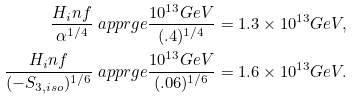<formula> <loc_0><loc_0><loc_500><loc_500>\frac { H _ { i } n f } { \alpha ^ { 1 / 4 } } & \ a p p r g e \frac { 1 0 ^ { 1 3 } G e V } { ( . 4 ) ^ { 1 / 4 } } = 1 . 3 \times 1 0 ^ { 1 3 } G e V , \\ \frac { H _ { i } n f } { ( - S _ { 3 , i s o } ) ^ { 1 / 6 } } & \ a p p r g e \frac { 1 0 ^ { 1 3 } G e V } { ( . 0 6 ) ^ { 1 / 6 } } = 1 . 6 \times 1 0 ^ { 1 3 } G e V .</formula> 